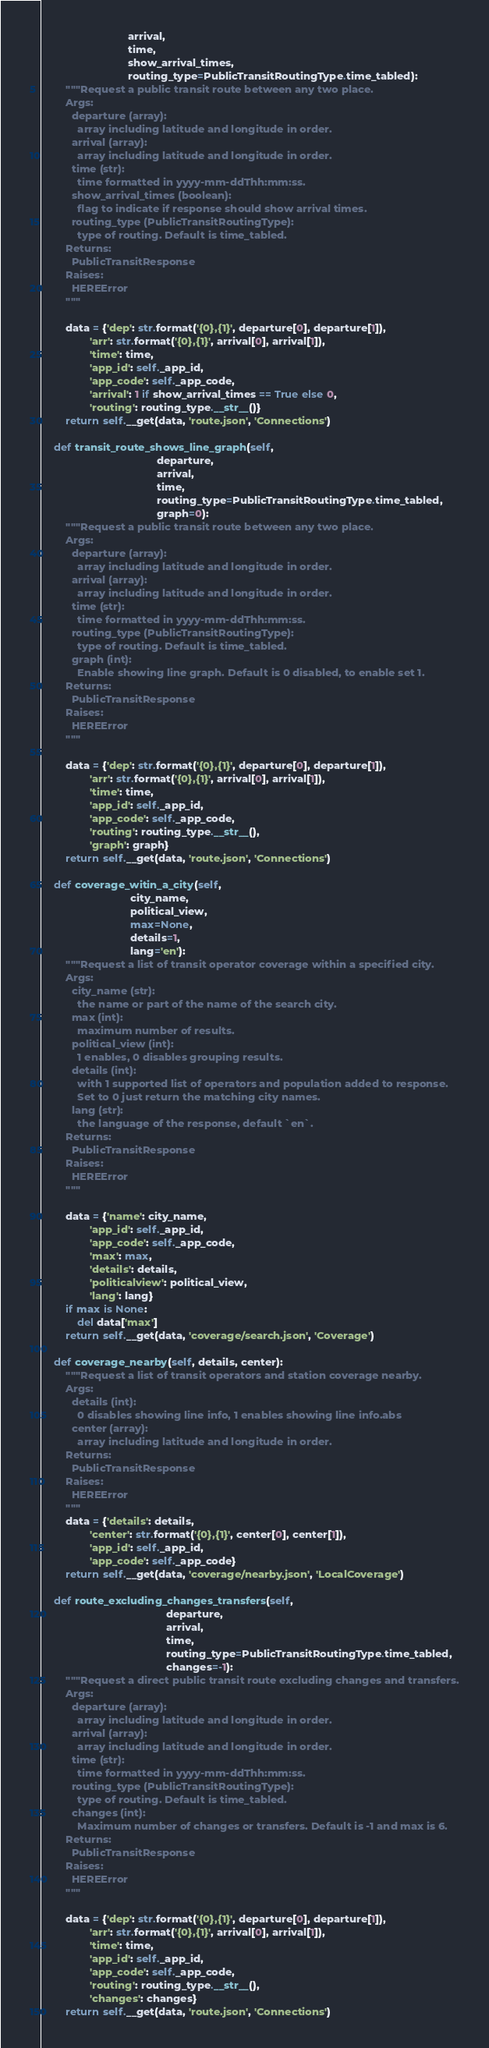Convert code to text. <code><loc_0><loc_0><loc_500><loc_500><_Python_>                             arrival,
                             time,
                             show_arrival_times,
                             routing_type=PublicTransitRoutingType.time_tabled):
        """Request a public transit route between any two place.
        Args:
          departure (array):
            array including latitude and longitude in order.
          arrival (array):
            array including latitude and longitude in order.
          time (str):
            time formatted in yyyy-mm-ddThh:mm:ss.
          show_arrival_times (boolean):
            flag to indicate if response should show arrival times.
          routing_type (PublicTransitRoutingType):
            type of routing. Default is time_tabled.
        Returns:
          PublicTransitResponse
        Raises:
          HEREError
        """

        data = {'dep': str.format('{0},{1}', departure[0], departure[1]),
                'arr': str.format('{0},{1}', arrival[0], arrival[1]),
                'time': time,
                'app_id': self._app_id,
                'app_code': self._app_code,
                'arrival': 1 if show_arrival_times == True else 0,
                'routing': routing_type.__str__()}
        return self.__get(data, 'route.json', 'Connections')

    def transit_route_shows_line_graph(self,
                                       departure,
                                       arrival,
                                       time,
                                       routing_type=PublicTransitRoutingType.time_tabled,
                                       graph=0):
        """Request a public transit route between any two place.
        Args:
          departure (array):
            array including latitude and longitude in order.
          arrival (array):
            array including latitude and longitude in order.
          time (str):
            time formatted in yyyy-mm-ddThh:mm:ss.
          routing_type (PublicTransitRoutingType):
            type of routing. Default is time_tabled.
          graph (int):
            Enable showing line graph. Default is 0 disabled, to enable set 1.
        Returns:
          PublicTransitResponse
        Raises:
          HEREError
        """

        data = {'dep': str.format('{0},{1}', departure[0], departure[1]),
                'arr': str.format('{0},{1}', arrival[0], arrival[1]),
                'time': time,
                'app_id': self._app_id,
                'app_code': self._app_code,
                'routing': routing_type.__str__(),
                'graph': graph}
        return self.__get(data, 'route.json', 'Connections')

    def coverage_witin_a_city(self,
                              city_name,
                              political_view,
                              max=None,
                              details=1,
                              lang='en'):
        """Request a list of transit operator coverage within a specified city.
        Args:
          city_name (str):
            the name or part of the name of the search city.
          max (int):
            maximum number of results.
          political_view (int):
            1 enables, 0 disables grouping results.
          details (int):
            with 1 supported list of operators and population added to response.
            Set to 0 just return the matching city names.
          lang (str):
            the language of the response, default `en`.
        Returns:
          PublicTransitResponse
        Raises:
          HEREError
        """

        data = {'name': city_name,
                'app_id': self._app_id,
                'app_code': self._app_code,
                'max': max,
                'details': details,
                'politicalview': political_view,
                'lang': lang}
        if max is None:
            del data['max']
        return self.__get(data, 'coverage/search.json', 'Coverage')

    def coverage_nearby(self, details, center):
        """Request a list of transit operators and station coverage nearby.
        Args:
          details (int):
            0 disables showing line info, 1 enables showing line info.abs
          center (array):
            array including latitude and longitude in order.
        Returns:
          PublicTransitResponse
        Raises:
          HEREError
        """
        data = {'details': details,
                'center': str.format('{0},{1}', center[0], center[1]),
                'app_id': self._app_id,
                'app_code': self._app_code}
        return self.__get(data, 'coverage/nearby.json', 'LocalCoverage')

    def route_excluding_changes_transfers(self,
                                          departure,
                                          arrival,
                                          time,
                                          routing_type=PublicTransitRoutingType.time_tabled,
                                          changes=-1):
        """Request a direct public transit route excluding changes and transfers.
        Args:
          departure (array):
            array including latitude and longitude in order.
          arrival (array):
            array including latitude and longitude in order.
          time (str):
            time formatted in yyyy-mm-ddThh:mm:ss.
          routing_type (PublicTransitRoutingType):
            type of routing. Default is time_tabled.
          changes (int):
            Maximum number of changes or transfers. Default is -1 and max is 6.
        Returns:
          PublicTransitResponse
        Raises:
          HEREError
        """

        data = {'dep': str.format('{0},{1}', departure[0], departure[1]),
                'arr': str.format('{0},{1}', arrival[0], arrival[1]),
                'time': time,
                'app_id': self._app_id,
                'app_code': self._app_code,
                'routing': routing_type.__str__(),
                'changes': changes}
        return self.__get(data, 'route.json', 'Connections')
</code> 